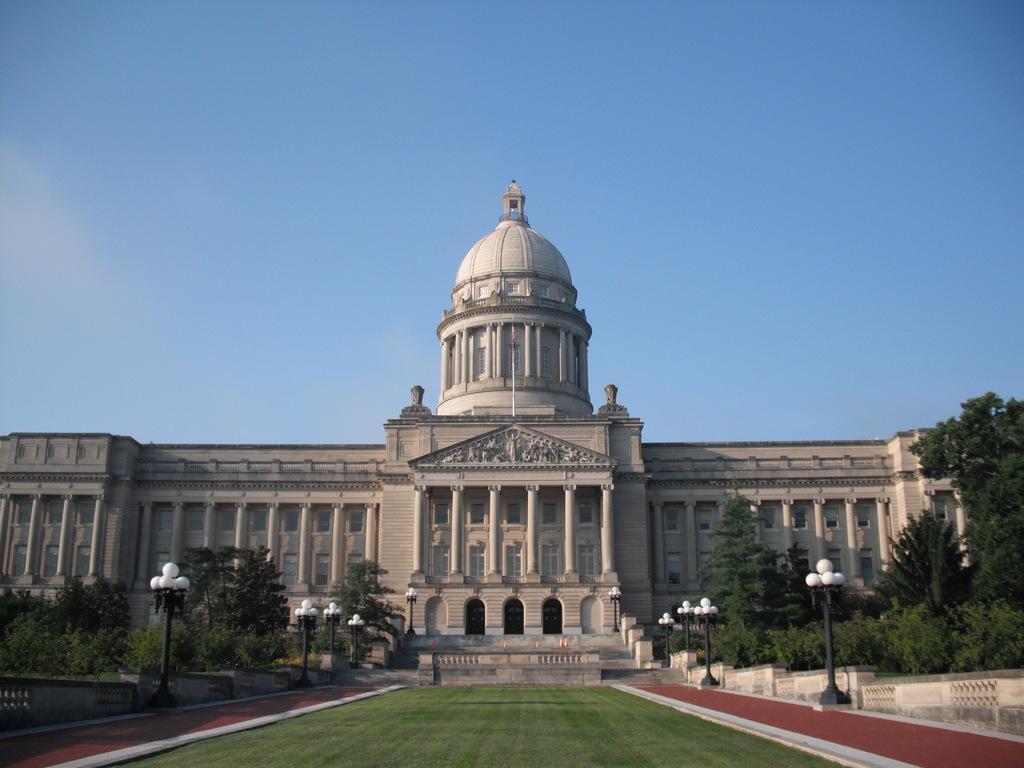How would you summarize this image in a sentence or two? In this image in the center there is one building and at the bottom there is walkway, on the right side and left side there are some trees, poles and lights. At the top of the image there is sky. 